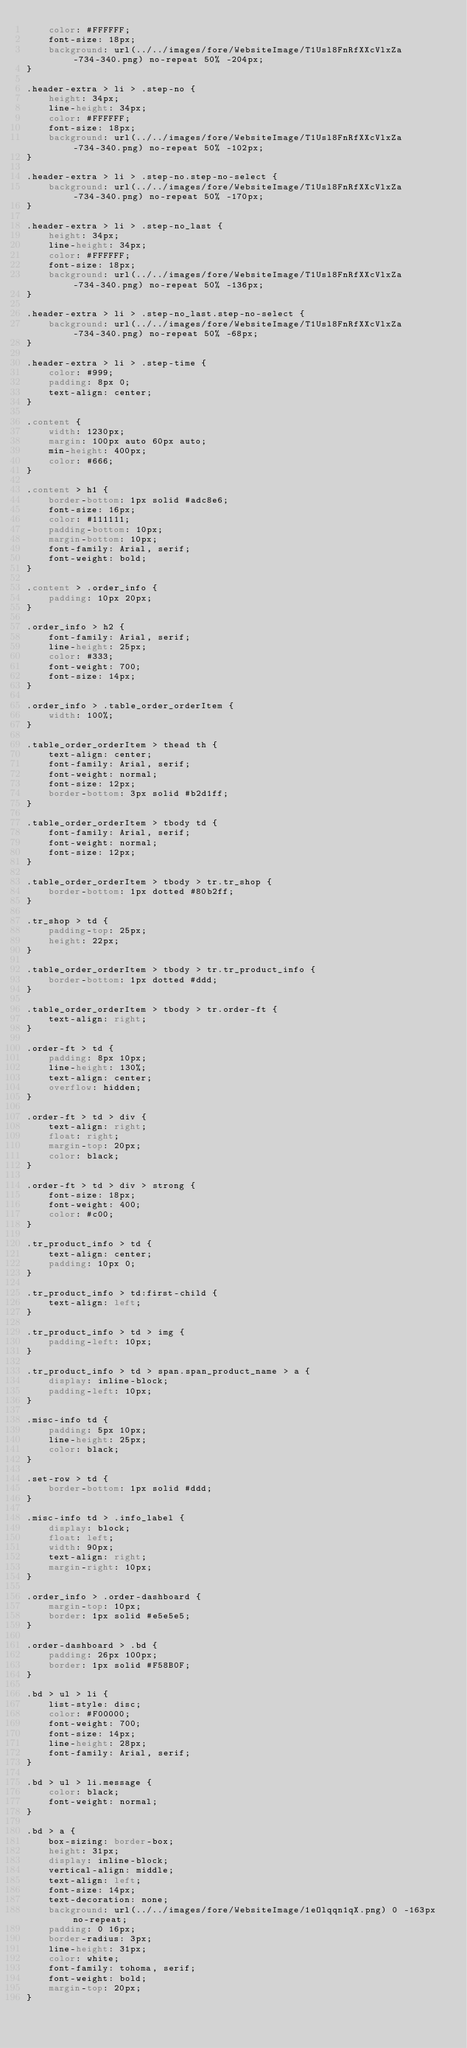Convert code to text. <code><loc_0><loc_0><loc_500><loc_500><_CSS_>    color: #FFFFFF;
    font-size: 18px;
    background: url(../../images/fore/WebsiteImage/T1Usl8FnRfXXcVlxZa-734-340.png) no-repeat 50% -204px;
}

.header-extra > li > .step-no {
    height: 34px;
    line-height: 34px;
    color: #FFFFFF;
    font-size: 18px;
    background: url(../../images/fore/WebsiteImage/T1Usl8FnRfXXcVlxZa-734-340.png) no-repeat 50% -102px;
}

.header-extra > li > .step-no.step-no-select {
    background: url(../../images/fore/WebsiteImage/T1Usl8FnRfXXcVlxZa-734-340.png) no-repeat 50% -170px;
}

.header-extra > li > .step-no_last {
    height: 34px;
    line-height: 34px;
    color: #FFFFFF;
    font-size: 18px;
    background: url(../../images/fore/WebsiteImage/T1Usl8FnRfXXcVlxZa-734-340.png) no-repeat 50% -136px;
}

.header-extra > li > .step-no_last.step-no-select {
    background: url(../../images/fore/WebsiteImage/T1Usl8FnRfXXcVlxZa-734-340.png) no-repeat 50% -68px;
}

.header-extra > li > .step-time {
    color: #999;
    padding: 8px 0;
    text-align: center;
}

.content {
    width: 1230px;
    margin: 100px auto 60px auto;
    min-height: 400px;
    color: #666;
}

.content > h1 {
    border-bottom: 1px solid #adc8e6;
    font-size: 16px;
    color: #111111;
    padding-bottom: 10px;
    margin-bottom: 10px;
    font-family: Arial, serif;
    font-weight: bold;
}

.content > .order_info {
    padding: 10px 20px;
}

.order_info > h2 {
    font-family: Arial, serif;
    line-height: 25px;
    color: #333;
    font-weight: 700;
    font-size: 14px;
}

.order_info > .table_order_orderItem {
    width: 100%;
}

.table_order_orderItem > thead th {
    text-align: center;
    font-family: Arial, serif;
    font-weight: normal;
    font-size: 12px;
    border-bottom: 3px solid #b2d1ff;
}

.table_order_orderItem > tbody td {
    font-family: Arial, serif;
    font-weight: normal;
    font-size: 12px;
}

.table_order_orderItem > tbody > tr.tr_shop {
    border-bottom: 1px dotted #80b2ff;
}

.tr_shop > td {
    padding-top: 25px;
    height: 22px;
}

.table_order_orderItem > tbody > tr.tr_product_info {
    border-bottom: 1px dotted #ddd;
}

.table_order_orderItem > tbody > tr.order-ft {
    text-align: right;
}

.order-ft > td {
    padding: 8px 10px;
    line-height: 130%;
    text-align: center;
    overflow: hidden;
}

.order-ft > td > div {
    text-align: right;
    float: right;
    margin-top: 20px;
    color: black;
}

.order-ft > td > div > strong {
    font-size: 18px;
    font-weight: 400;
    color: #c00;
}

.tr_product_info > td {
    text-align: center;
    padding: 10px 0;
}

.tr_product_info > td:first-child {
    text-align: left;
}

.tr_product_info > td > img {
    padding-left: 10px;
}

.tr_product_info > td > span.span_product_name > a {
    display: inline-block;
    padding-left: 10px;
}

.misc-info td {
    padding: 5px 10px;
    line-height: 25px;
    color: black;
}

.set-row > td {
    border-bottom: 1px solid #ddd;
}

.misc-info td > .info_label {
    display: block;
    float: left;
    width: 90px;
    text-align: right;
    margin-right: 10px;
}

.order_info > .order-dashboard {
    margin-top: 10px;
    border: 1px solid #e5e5e5;
}

.order-dashboard > .bd {
    padding: 26px 100px;
    border: 1px solid #F58B0F;
}

.bd > ul > li {
    list-style: disc;
    color: #F00000;
    font-weight: 700;
    font-size: 14px;
    line-height: 28px;
    font-family: Arial, serif;
}

.bd > ul > li.message {
    color: black;
    font-weight: normal;
}

.bd > a {
    box-sizing: border-box;
    height: 31px;
    display: inline-block;
    vertical-align: middle;
    text-align: left;
    font-size: 14px;
    text-decoration: none;
    background: url(../../images/fore/WebsiteImage/1eOlqqn1qX.png) 0 -163px no-repeat;
    padding: 0 16px;
    border-radius: 3px;
    line-height: 31px;
    color: white;
    font-family: tohoma, serif;
    font-weight: bold;
    margin-top: 20px;
}</code> 